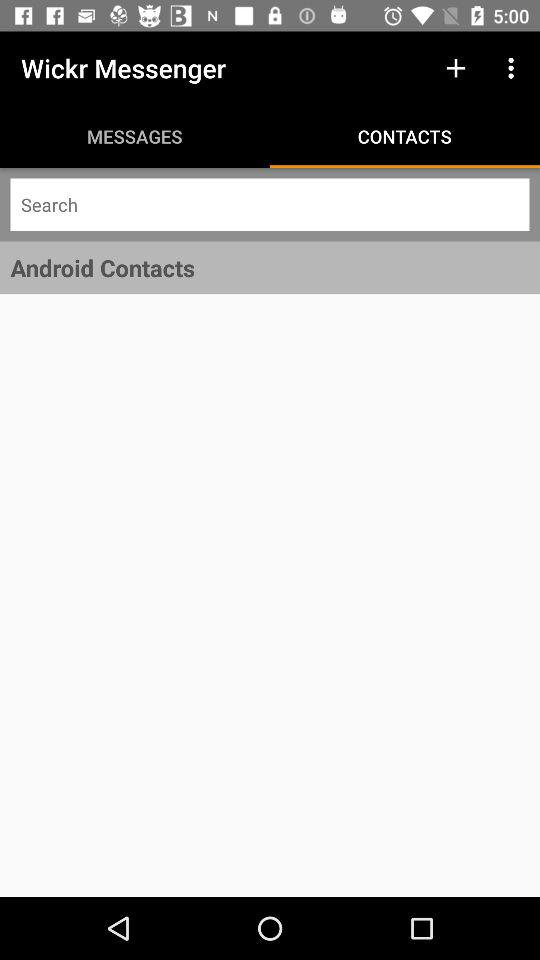What is the name of the application? The name of the application is "Wickr Messenger". 